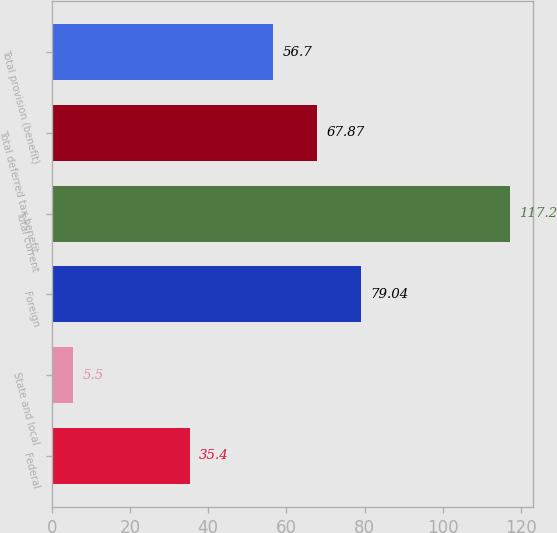<chart> <loc_0><loc_0><loc_500><loc_500><bar_chart><fcel>Federal<fcel>State and local<fcel>Foreign<fcel>Total current<fcel>Total deferred tax benefit<fcel>Total provision (benefit)<nl><fcel>35.4<fcel>5.5<fcel>79.04<fcel>117.2<fcel>67.87<fcel>56.7<nl></chart> 